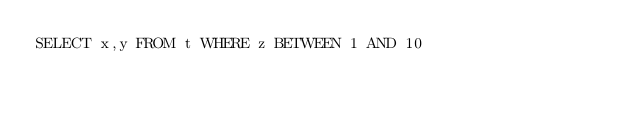Convert code to text. <code><loc_0><loc_0><loc_500><loc_500><_SQL_>SELECT x,y FROM t WHERE z BETWEEN 1 AND 10</code> 